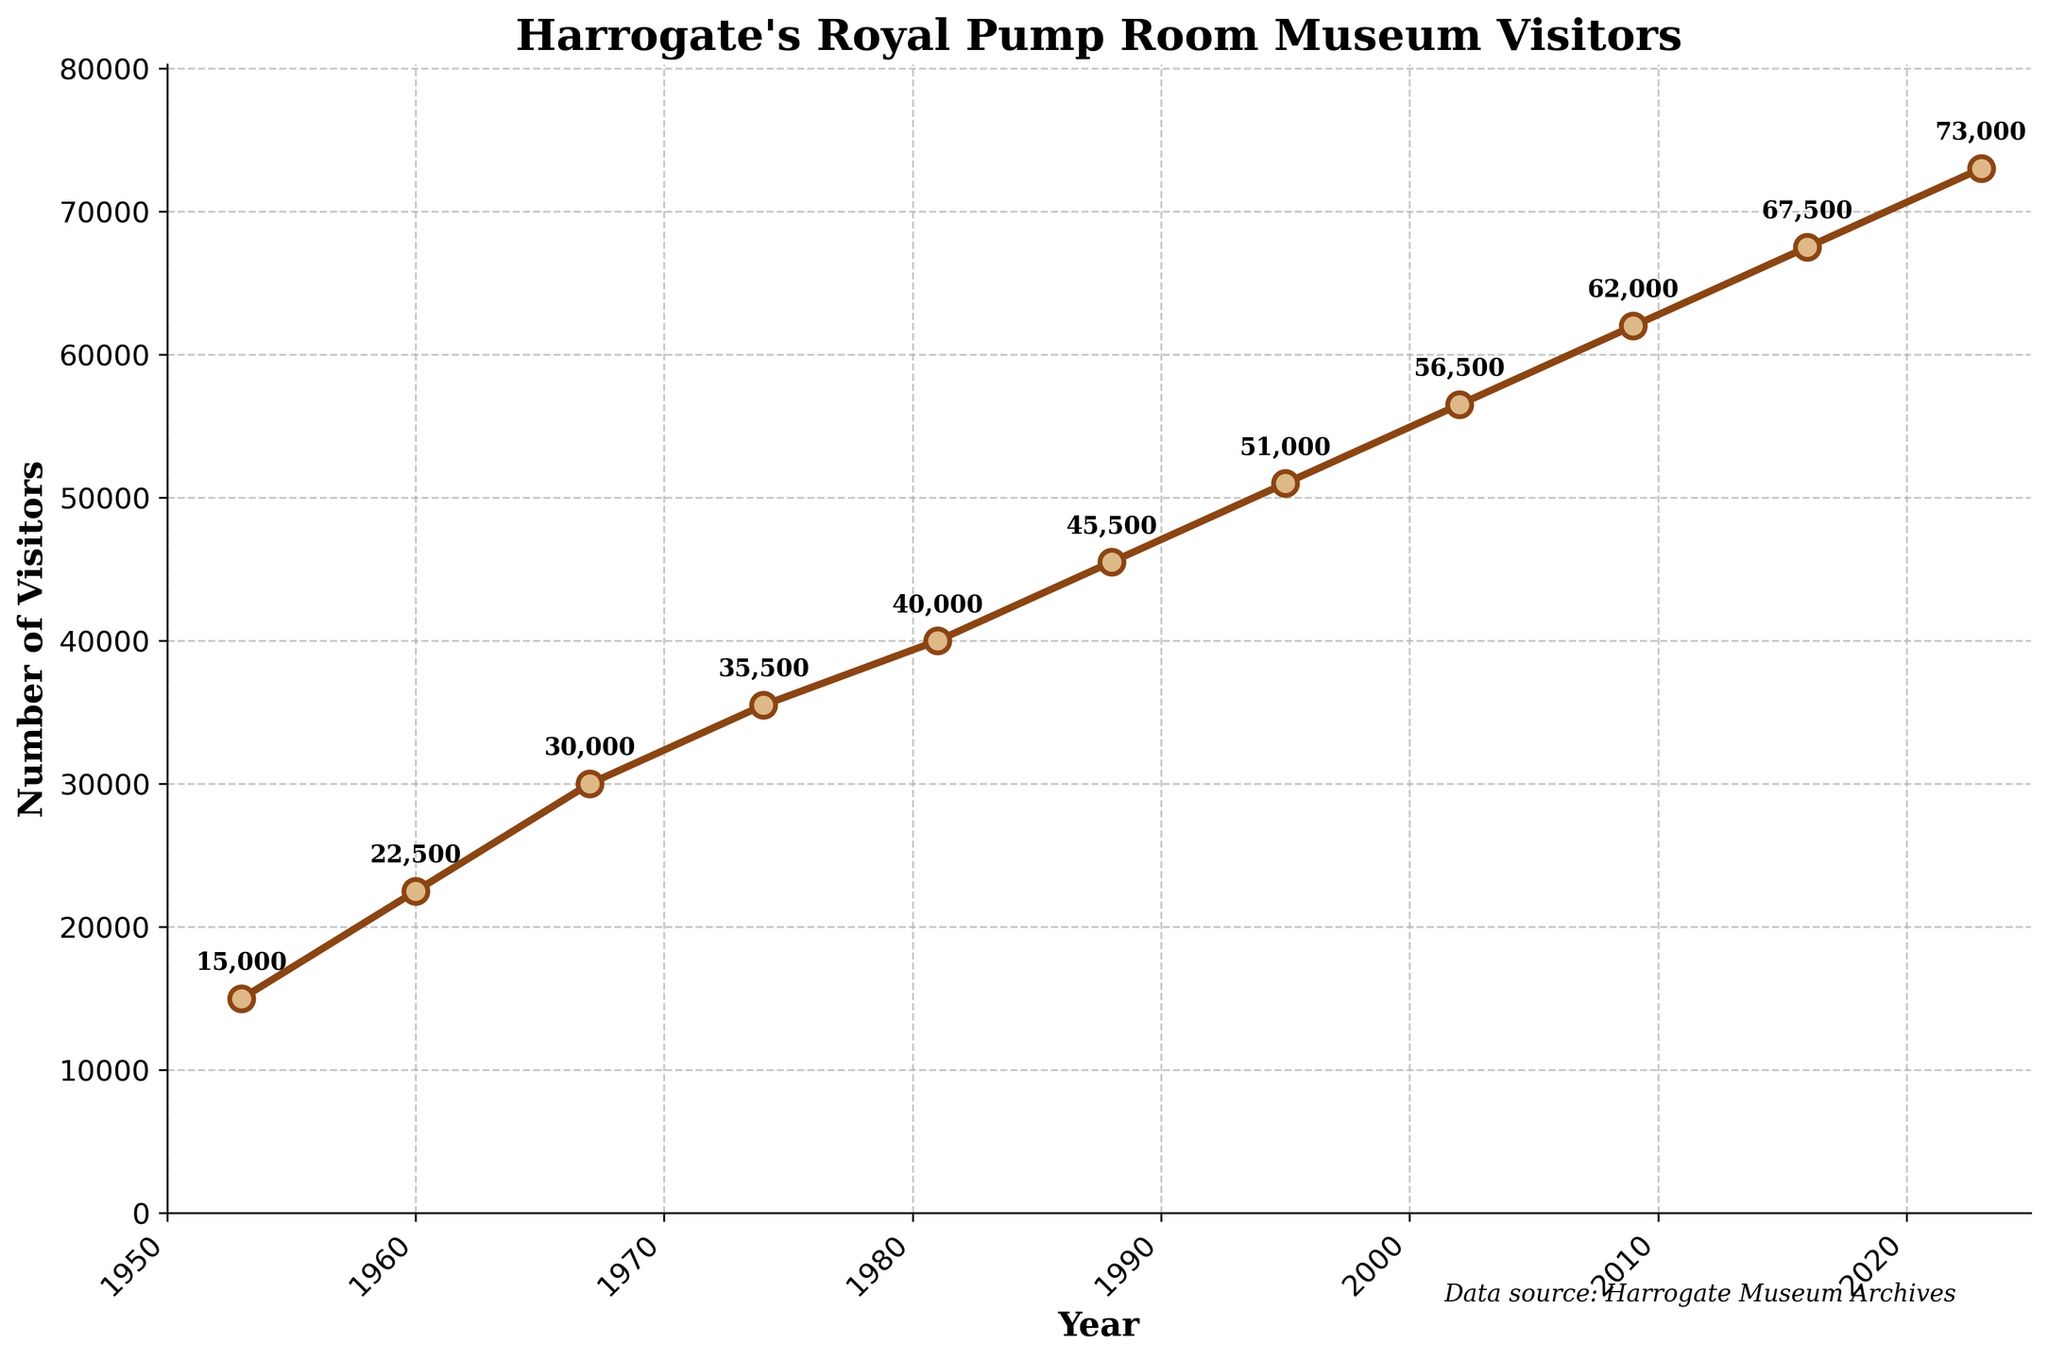What was the number of visitors when the museum first opened? The figure shows the number of visitors in 1953, the year the museum opened. The data point in that year indicates 15,000 visitors.
Answer: 15,000 In what year did the museum see a visitor count of over 50,000 for the first time? By looking at the line chart and the annotated visitor counts, the first year with over 50,000 visitors is 1995.
Answer: 1995 How many visitors did the museum gain from 1953 to 2023? The number of visitors in 1953 was 15,000, and in 2023 it was 73,000. The gain is 73,000 - 15,000 = 58,000.
Answer: 58,000 Compare the number of visitors in 1981 and 1988. Which year had more visitors? From the figure, 1981 had 40,000 visitors and 1988 had 45,500 visitors. Therefore, 1988 had more visitors.
Answer: 1988 Between 2009 and 2023, how many visitors did the museum gain on average per year? The number of visitors in 2009 is 62,000 and in 2023 is 73,000. The difference is 73,000 - 62,000 = 11,000. There are 2023 - 2009 = 14 years, so the average gain per year is 11,000 / 14 ≈ 785.7 or approximately 786.
Answer: 786 What was the highest recorded number of visitors and in which year did it occur? The highest number of visitors is 73,000, which occurred in 2023, as shown by the final data point on the chart.
Answer: 73,000, 2023 How does the trend of visitors change from 1953 to 2023? Analyzing the line chart, the trend shows a consistent increase in the number of visitors over the years with no visible declines, signifying a continuous rise in popularity of the museum.
Answer: Consistent increase 